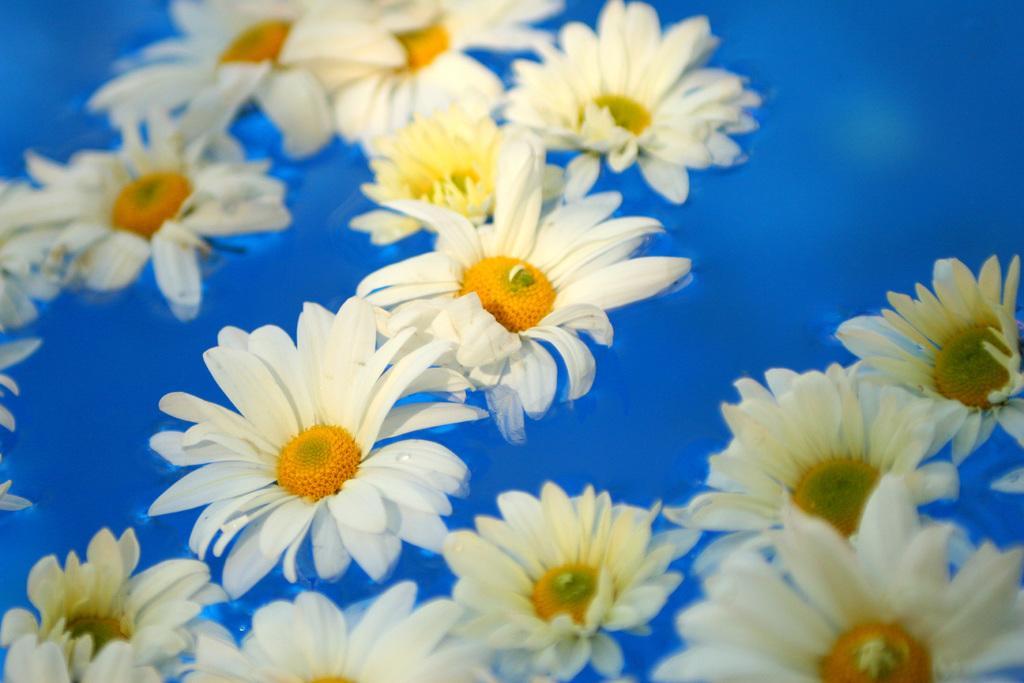How would you summarize this image in a sentence or two? In this picture we can see some flowers, at the bottom there is water, we can see petals of these flowers. 